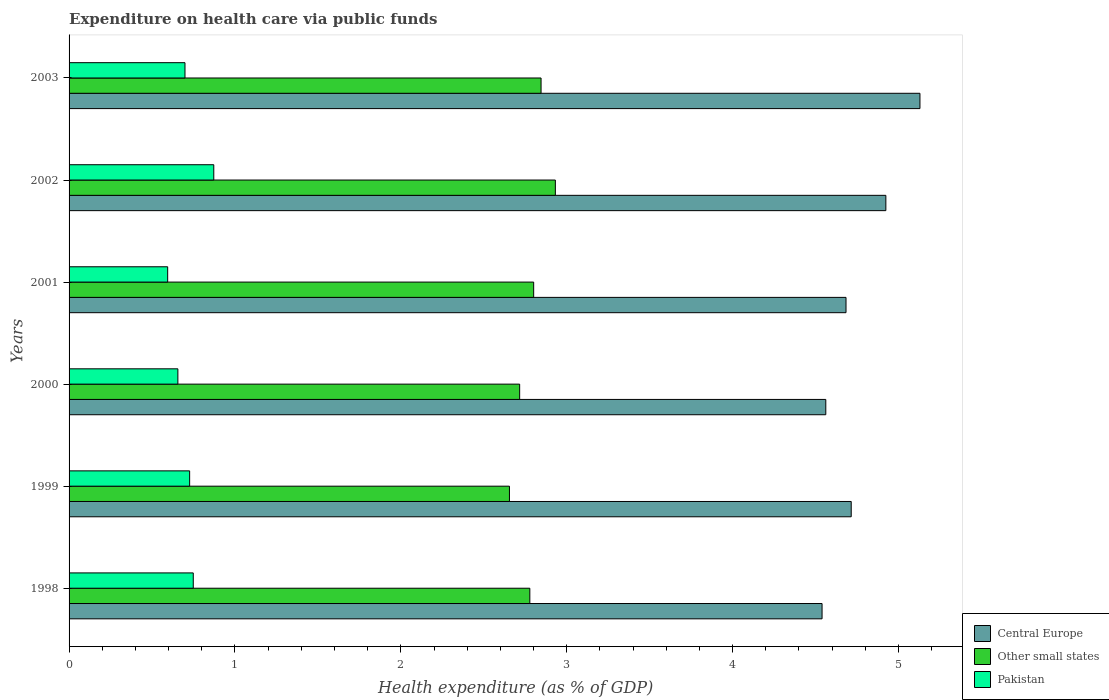How many groups of bars are there?
Ensure brevity in your answer.  6. How many bars are there on the 4th tick from the bottom?
Your answer should be very brief. 3. In how many cases, is the number of bars for a given year not equal to the number of legend labels?
Give a very brief answer. 0. What is the expenditure made on health care in Other small states in 2003?
Ensure brevity in your answer.  2.85. Across all years, what is the maximum expenditure made on health care in Other small states?
Provide a succinct answer. 2.93. Across all years, what is the minimum expenditure made on health care in Central Europe?
Make the answer very short. 4.54. In which year was the expenditure made on health care in Pakistan maximum?
Give a very brief answer. 2002. In which year was the expenditure made on health care in Other small states minimum?
Your response must be concise. 1999. What is the total expenditure made on health care in Pakistan in the graph?
Your answer should be compact. 4.3. What is the difference between the expenditure made on health care in Pakistan in 1998 and that in 2002?
Make the answer very short. -0.12. What is the difference between the expenditure made on health care in Other small states in 1998 and the expenditure made on health care in Pakistan in 2003?
Offer a very short reply. 2.08. What is the average expenditure made on health care in Other small states per year?
Give a very brief answer. 2.79. In the year 1999, what is the difference between the expenditure made on health care in Central Europe and expenditure made on health care in Pakistan?
Your response must be concise. 3.99. In how many years, is the expenditure made on health care in Pakistan greater than 4 %?
Offer a very short reply. 0. What is the ratio of the expenditure made on health care in Other small states in 2001 to that in 2003?
Your answer should be very brief. 0.98. Is the expenditure made on health care in Other small states in 2000 less than that in 2003?
Provide a short and direct response. Yes. What is the difference between the highest and the second highest expenditure made on health care in Pakistan?
Your response must be concise. 0.12. What is the difference between the highest and the lowest expenditure made on health care in Central Europe?
Your response must be concise. 0.59. What does the 1st bar from the top in 2002 represents?
Your answer should be compact. Pakistan. What does the 3rd bar from the bottom in 2001 represents?
Make the answer very short. Pakistan. Is it the case that in every year, the sum of the expenditure made on health care in Pakistan and expenditure made on health care in Other small states is greater than the expenditure made on health care in Central Europe?
Provide a short and direct response. No. How many bars are there?
Offer a terse response. 18. Are all the bars in the graph horizontal?
Make the answer very short. Yes. How many years are there in the graph?
Ensure brevity in your answer.  6. Does the graph contain grids?
Provide a succinct answer. No. How many legend labels are there?
Make the answer very short. 3. What is the title of the graph?
Provide a succinct answer. Expenditure on health care via public funds. What is the label or title of the X-axis?
Ensure brevity in your answer.  Health expenditure (as % of GDP). What is the Health expenditure (as % of GDP) in Central Europe in 1998?
Give a very brief answer. 4.54. What is the Health expenditure (as % of GDP) of Other small states in 1998?
Keep it short and to the point. 2.78. What is the Health expenditure (as % of GDP) in Pakistan in 1998?
Your answer should be compact. 0.75. What is the Health expenditure (as % of GDP) in Central Europe in 1999?
Give a very brief answer. 4.72. What is the Health expenditure (as % of GDP) in Other small states in 1999?
Your answer should be compact. 2.65. What is the Health expenditure (as % of GDP) in Pakistan in 1999?
Give a very brief answer. 0.73. What is the Health expenditure (as % of GDP) of Central Europe in 2000?
Your response must be concise. 4.56. What is the Health expenditure (as % of GDP) in Other small states in 2000?
Your response must be concise. 2.72. What is the Health expenditure (as % of GDP) in Pakistan in 2000?
Your response must be concise. 0.66. What is the Health expenditure (as % of GDP) in Central Europe in 2001?
Your answer should be compact. 4.68. What is the Health expenditure (as % of GDP) of Other small states in 2001?
Your response must be concise. 2.8. What is the Health expenditure (as % of GDP) of Pakistan in 2001?
Offer a very short reply. 0.59. What is the Health expenditure (as % of GDP) in Central Europe in 2002?
Your response must be concise. 4.92. What is the Health expenditure (as % of GDP) in Other small states in 2002?
Make the answer very short. 2.93. What is the Health expenditure (as % of GDP) of Pakistan in 2002?
Provide a succinct answer. 0.87. What is the Health expenditure (as % of GDP) in Central Europe in 2003?
Make the answer very short. 5.13. What is the Health expenditure (as % of GDP) in Other small states in 2003?
Offer a terse response. 2.85. What is the Health expenditure (as % of GDP) of Pakistan in 2003?
Give a very brief answer. 0.7. Across all years, what is the maximum Health expenditure (as % of GDP) of Central Europe?
Offer a very short reply. 5.13. Across all years, what is the maximum Health expenditure (as % of GDP) in Other small states?
Offer a terse response. 2.93. Across all years, what is the maximum Health expenditure (as % of GDP) of Pakistan?
Ensure brevity in your answer.  0.87. Across all years, what is the minimum Health expenditure (as % of GDP) of Central Europe?
Make the answer very short. 4.54. Across all years, what is the minimum Health expenditure (as % of GDP) in Other small states?
Keep it short and to the point. 2.65. Across all years, what is the minimum Health expenditure (as % of GDP) of Pakistan?
Make the answer very short. 0.59. What is the total Health expenditure (as % of GDP) of Central Europe in the graph?
Your answer should be compact. 28.55. What is the total Health expenditure (as % of GDP) in Other small states in the graph?
Your answer should be compact. 16.73. What is the total Health expenditure (as % of GDP) of Pakistan in the graph?
Your answer should be very brief. 4.3. What is the difference between the Health expenditure (as % of GDP) in Central Europe in 1998 and that in 1999?
Offer a terse response. -0.18. What is the difference between the Health expenditure (as % of GDP) of Other small states in 1998 and that in 1999?
Provide a short and direct response. 0.12. What is the difference between the Health expenditure (as % of GDP) in Pakistan in 1998 and that in 1999?
Your answer should be very brief. 0.02. What is the difference between the Health expenditure (as % of GDP) in Central Europe in 1998 and that in 2000?
Your answer should be compact. -0.02. What is the difference between the Health expenditure (as % of GDP) of Other small states in 1998 and that in 2000?
Make the answer very short. 0.06. What is the difference between the Health expenditure (as % of GDP) in Pakistan in 1998 and that in 2000?
Offer a terse response. 0.09. What is the difference between the Health expenditure (as % of GDP) of Central Europe in 1998 and that in 2001?
Provide a short and direct response. -0.14. What is the difference between the Health expenditure (as % of GDP) in Other small states in 1998 and that in 2001?
Provide a short and direct response. -0.02. What is the difference between the Health expenditure (as % of GDP) in Pakistan in 1998 and that in 2001?
Ensure brevity in your answer.  0.15. What is the difference between the Health expenditure (as % of GDP) of Central Europe in 1998 and that in 2002?
Provide a short and direct response. -0.38. What is the difference between the Health expenditure (as % of GDP) of Other small states in 1998 and that in 2002?
Your answer should be very brief. -0.15. What is the difference between the Health expenditure (as % of GDP) in Pakistan in 1998 and that in 2002?
Keep it short and to the point. -0.12. What is the difference between the Health expenditure (as % of GDP) in Central Europe in 1998 and that in 2003?
Offer a very short reply. -0.59. What is the difference between the Health expenditure (as % of GDP) of Other small states in 1998 and that in 2003?
Offer a terse response. -0.07. What is the difference between the Health expenditure (as % of GDP) of Pakistan in 1998 and that in 2003?
Provide a succinct answer. 0.05. What is the difference between the Health expenditure (as % of GDP) of Central Europe in 1999 and that in 2000?
Keep it short and to the point. 0.15. What is the difference between the Health expenditure (as % of GDP) of Other small states in 1999 and that in 2000?
Offer a terse response. -0.06. What is the difference between the Health expenditure (as % of GDP) in Pakistan in 1999 and that in 2000?
Your answer should be compact. 0.07. What is the difference between the Health expenditure (as % of GDP) of Central Europe in 1999 and that in 2001?
Your answer should be compact. 0.03. What is the difference between the Health expenditure (as % of GDP) in Other small states in 1999 and that in 2001?
Make the answer very short. -0.15. What is the difference between the Health expenditure (as % of GDP) of Pakistan in 1999 and that in 2001?
Make the answer very short. 0.13. What is the difference between the Health expenditure (as % of GDP) of Central Europe in 1999 and that in 2002?
Your response must be concise. -0.21. What is the difference between the Health expenditure (as % of GDP) in Other small states in 1999 and that in 2002?
Keep it short and to the point. -0.28. What is the difference between the Health expenditure (as % of GDP) in Pakistan in 1999 and that in 2002?
Provide a succinct answer. -0.15. What is the difference between the Health expenditure (as % of GDP) in Central Europe in 1999 and that in 2003?
Offer a very short reply. -0.41. What is the difference between the Health expenditure (as % of GDP) in Other small states in 1999 and that in 2003?
Ensure brevity in your answer.  -0.19. What is the difference between the Health expenditure (as % of GDP) of Pakistan in 1999 and that in 2003?
Provide a short and direct response. 0.03. What is the difference between the Health expenditure (as % of GDP) in Central Europe in 2000 and that in 2001?
Give a very brief answer. -0.12. What is the difference between the Health expenditure (as % of GDP) in Other small states in 2000 and that in 2001?
Keep it short and to the point. -0.08. What is the difference between the Health expenditure (as % of GDP) in Pakistan in 2000 and that in 2001?
Ensure brevity in your answer.  0.06. What is the difference between the Health expenditure (as % of GDP) of Central Europe in 2000 and that in 2002?
Provide a succinct answer. -0.36. What is the difference between the Health expenditure (as % of GDP) in Other small states in 2000 and that in 2002?
Ensure brevity in your answer.  -0.22. What is the difference between the Health expenditure (as % of GDP) of Pakistan in 2000 and that in 2002?
Offer a terse response. -0.22. What is the difference between the Health expenditure (as % of GDP) in Central Europe in 2000 and that in 2003?
Your answer should be compact. -0.57. What is the difference between the Health expenditure (as % of GDP) in Other small states in 2000 and that in 2003?
Offer a terse response. -0.13. What is the difference between the Health expenditure (as % of GDP) of Pakistan in 2000 and that in 2003?
Ensure brevity in your answer.  -0.04. What is the difference between the Health expenditure (as % of GDP) of Central Europe in 2001 and that in 2002?
Your answer should be compact. -0.24. What is the difference between the Health expenditure (as % of GDP) in Other small states in 2001 and that in 2002?
Keep it short and to the point. -0.13. What is the difference between the Health expenditure (as % of GDP) of Pakistan in 2001 and that in 2002?
Offer a terse response. -0.28. What is the difference between the Health expenditure (as % of GDP) of Central Europe in 2001 and that in 2003?
Ensure brevity in your answer.  -0.45. What is the difference between the Health expenditure (as % of GDP) of Other small states in 2001 and that in 2003?
Give a very brief answer. -0.04. What is the difference between the Health expenditure (as % of GDP) in Pakistan in 2001 and that in 2003?
Make the answer very short. -0.1. What is the difference between the Health expenditure (as % of GDP) in Central Europe in 2002 and that in 2003?
Provide a short and direct response. -0.21. What is the difference between the Health expenditure (as % of GDP) in Other small states in 2002 and that in 2003?
Give a very brief answer. 0.09. What is the difference between the Health expenditure (as % of GDP) in Pakistan in 2002 and that in 2003?
Give a very brief answer. 0.17. What is the difference between the Health expenditure (as % of GDP) in Central Europe in 1998 and the Health expenditure (as % of GDP) in Other small states in 1999?
Offer a terse response. 1.88. What is the difference between the Health expenditure (as % of GDP) in Central Europe in 1998 and the Health expenditure (as % of GDP) in Pakistan in 1999?
Ensure brevity in your answer.  3.81. What is the difference between the Health expenditure (as % of GDP) of Other small states in 1998 and the Health expenditure (as % of GDP) of Pakistan in 1999?
Make the answer very short. 2.05. What is the difference between the Health expenditure (as % of GDP) of Central Europe in 1998 and the Health expenditure (as % of GDP) of Other small states in 2000?
Ensure brevity in your answer.  1.82. What is the difference between the Health expenditure (as % of GDP) of Central Europe in 1998 and the Health expenditure (as % of GDP) of Pakistan in 2000?
Your answer should be compact. 3.88. What is the difference between the Health expenditure (as % of GDP) in Other small states in 1998 and the Health expenditure (as % of GDP) in Pakistan in 2000?
Offer a terse response. 2.12. What is the difference between the Health expenditure (as % of GDP) in Central Europe in 1998 and the Health expenditure (as % of GDP) in Other small states in 2001?
Make the answer very short. 1.74. What is the difference between the Health expenditure (as % of GDP) in Central Europe in 1998 and the Health expenditure (as % of GDP) in Pakistan in 2001?
Your response must be concise. 3.94. What is the difference between the Health expenditure (as % of GDP) in Other small states in 1998 and the Health expenditure (as % of GDP) in Pakistan in 2001?
Make the answer very short. 2.18. What is the difference between the Health expenditure (as % of GDP) in Central Europe in 1998 and the Health expenditure (as % of GDP) in Other small states in 2002?
Offer a terse response. 1.61. What is the difference between the Health expenditure (as % of GDP) of Central Europe in 1998 and the Health expenditure (as % of GDP) of Pakistan in 2002?
Give a very brief answer. 3.67. What is the difference between the Health expenditure (as % of GDP) in Other small states in 1998 and the Health expenditure (as % of GDP) in Pakistan in 2002?
Your answer should be compact. 1.91. What is the difference between the Health expenditure (as % of GDP) of Central Europe in 1998 and the Health expenditure (as % of GDP) of Other small states in 2003?
Your response must be concise. 1.69. What is the difference between the Health expenditure (as % of GDP) in Central Europe in 1998 and the Health expenditure (as % of GDP) in Pakistan in 2003?
Offer a terse response. 3.84. What is the difference between the Health expenditure (as % of GDP) in Other small states in 1998 and the Health expenditure (as % of GDP) in Pakistan in 2003?
Offer a terse response. 2.08. What is the difference between the Health expenditure (as % of GDP) of Central Europe in 1999 and the Health expenditure (as % of GDP) of Other small states in 2000?
Offer a very short reply. 2. What is the difference between the Health expenditure (as % of GDP) in Central Europe in 1999 and the Health expenditure (as % of GDP) in Pakistan in 2000?
Provide a short and direct response. 4.06. What is the difference between the Health expenditure (as % of GDP) in Other small states in 1999 and the Health expenditure (as % of GDP) in Pakistan in 2000?
Your answer should be compact. 2. What is the difference between the Health expenditure (as % of GDP) of Central Europe in 1999 and the Health expenditure (as % of GDP) of Other small states in 2001?
Your answer should be compact. 1.91. What is the difference between the Health expenditure (as % of GDP) in Central Europe in 1999 and the Health expenditure (as % of GDP) in Pakistan in 2001?
Ensure brevity in your answer.  4.12. What is the difference between the Health expenditure (as % of GDP) of Other small states in 1999 and the Health expenditure (as % of GDP) of Pakistan in 2001?
Make the answer very short. 2.06. What is the difference between the Health expenditure (as % of GDP) in Central Europe in 1999 and the Health expenditure (as % of GDP) in Other small states in 2002?
Make the answer very short. 1.78. What is the difference between the Health expenditure (as % of GDP) in Central Europe in 1999 and the Health expenditure (as % of GDP) in Pakistan in 2002?
Provide a short and direct response. 3.84. What is the difference between the Health expenditure (as % of GDP) in Other small states in 1999 and the Health expenditure (as % of GDP) in Pakistan in 2002?
Make the answer very short. 1.78. What is the difference between the Health expenditure (as % of GDP) of Central Europe in 1999 and the Health expenditure (as % of GDP) of Other small states in 2003?
Make the answer very short. 1.87. What is the difference between the Health expenditure (as % of GDP) in Central Europe in 1999 and the Health expenditure (as % of GDP) in Pakistan in 2003?
Offer a terse response. 4.02. What is the difference between the Health expenditure (as % of GDP) of Other small states in 1999 and the Health expenditure (as % of GDP) of Pakistan in 2003?
Ensure brevity in your answer.  1.96. What is the difference between the Health expenditure (as % of GDP) in Central Europe in 2000 and the Health expenditure (as % of GDP) in Other small states in 2001?
Your answer should be very brief. 1.76. What is the difference between the Health expenditure (as % of GDP) of Central Europe in 2000 and the Health expenditure (as % of GDP) of Pakistan in 2001?
Your answer should be very brief. 3.97. What is the difference between the Health expenditure (as % of GDP) of Other small states in 2000 and the Health expenditure (as % of GDP) of Pakistan in 2001?
Keep it short and to the point. 2.12. What is the difference between the Health expenditure (as % of GDP) of Central Europe in 2000 and the Health expenditure (as % of GDP) of Other small states in 2002?
Your answer should be compact. 1.63. What is the difference between the Health expenditure (as % of GDP) of Central Europe in 2000 and the Health expenditure (as % of GDP) of Pakistan in 2002?
Offer a very short reply. 3.69. What is the difference between the Health expenditure (as % of GDP) of Other small states in 2000 and the Health expenditure (as % of GDP) of Pakistan in 2002?
Offer a very short reply. 1.84. What is the difference between the Health expenditure (as % of GDP) of Central Europe in 2000 and the Health expenditure (as % of GDP) of Other small states in 2003?
Your answer should be compact. 1.72. What is the difference between the Health expenditure (as % of GDP) of Central Europe in 2000 and the Health expenditure (as % of GDP) of Pakistan in 2003?
Offer a terse response. 3.86. What is the difference between the Health expenditure (as % of GDP) in Other small states in 2000 and the Health expenditure (as % of GDP) in Pakistan in 2003?
Provide a succinct answer. 2.02. What is the difference between the Health expenditure (as % of GDP) in Central Europe in 2001 and the Health expenditure (as % of GDP) in Other small states in 2002?
Offer a very short reply. 1.75. What is the difference between the Health expenditure (as % of GDP) in Central Europe in 2001 and the Health expenditure (as % of GDP) in Pakistan in 2002?
Ensure brevity in your answer.  3.81. What is the difference between the Health expenditure (as % of GDP) of Other small states in 2001 and the Health expenditure (as % of GDP) of Pakistan in 2002?
Provide a short and direct response. 1.93. What is the difference between the Health expenditure (as % of GDP) in Central Europe in 2001 and the Health expenditure (as % of GDP) in Other small states in 2003?
Provide a succinct answer. 1.84. What is the difference between the Health expenditure (as % of GDP) in Central Europe in 2001 and the Health expenditure (as % of GDP) in Pakistan in 2003?
Your answer should be very brief. 3.98. What is the difference between the Health expenditure (as % of GDP) of Other small states in 2001 and the Health expenditure (as % of GDP) of Pakistan in 2003?
Your answer should be very brief. 2.1. What is the difference between the Health expenditure (as % of GDP) of Central Europe in 2002 and the Health expenditure (as % of GDP) of Other small states in 2003?
Your answer should be very brief. 2.08. What is the difference between the Health expenditure (as % of GDP) of Central Europe in 2002 and the Health expenditure (as % of GDP) of Pakistan in 2003?
Your response must be concise. 4.23. What is the difference between the Health expenditure (as % of GDP) in Other small states in 2002 and the Health expenditure (as % of GDP) in Pakistan in 2003?
Offer a terse response. 2.23. What is the average Health expenditure (as % of GDP) in Central Europe per year?
Make the answer very short. 4.76. What is the average Health expenditure (as % of GDP) of Other small states per year?
Offer a very short reply. 2.79. What is the average Health expenditure (as % of GDP) in Pakistan per year?
Provide a short and direct response. 0.72. In the year 1998, what is the difference between the Health expenditure (as % of GDP) in Central Europe and Health expenditure (as % of GDP) in Other small states?
Provide a succinct answer. 1.76. In the year 1998, what is the difference between the Health expenditure (as % of GDP) in Central Europe and Health expenditure (as % of GDP) in Pakistan?
Your answer should be compact. 3.79. In the year 1998, what is the difference between the Health expenditure (as % of GDP) of Other small states and Health expenditure (as % of GDP) of Pakistan?
Your answer should be very brief. 2.03. In the year 1999, what is the difference between the Health expenditure (as % of GDP) in Central Europe and Health expenditure (as % of GDP) in Other small states?
Ensure brevity in your answer.  2.06. In the year 1999, what is the difference between the Health expenditure (as % of GDP) in Central Europe and Health expenditure (as % of GDP) in Pakistan?
Keep it short and to the point. 3.99. In the year 1999, what is the difference between the Health expenditure (as % of GDP) in Other small states and Health expenditure (as % of GDP) in Pakistan?
Your response must be concise. 1.93. In the year 2000, what is the difference between the Health expenditure (as % of GDP) in Central Europe and Health expenditure (as % of GDP) in Other small states?
Ensure brevity in your answer.  1.85. In the year 2000, what is the difference between the Health expenditure (as % of GDP) in Central Europe and Health expenditure (as % of GDP) in Pakistan?
Provide a succinct answer. 3.91. In the year 2000, what is the difference between the Health expenditure (as % of GDP) of Other small states and Health expenditure (as % of GDP) of Pakistan?
Offer a very short reply. 2.06. In the year 2001, what is the difference between the Health expenditure (as % of GDP) of Central Europe and Health expenditure (as % of GDP) of Other small states?
Ensure brevity in your answer.  1.88. In the year 2001, what is the difference between the Health expenditure (as % of GDP) in Central Europe and Health expenditure (as % of GDP) in Pakistan?
Ensure brevity in your answer.  4.09. In the year 2001, what is the difference between the Health expenditure (as % of GDP) in Other small states and Health expenditure (as % of GDP) in Pakistan?
Offer a terse response. 2.21. In the year 2002, what is the difference between the Health expenditure (as % of GDP) in Central Europe and Health expenditure (as % of GDP) in Other small states?
Provide a succinct answer. 1.99. In the year 2002, what is the difference between the Health expenditure (as % of GDP) of Central Europe and Health expenditure (as % of GDP) of Pakistan?
Keep it short and to the point. 4.05. In the year 2002, what is the difference between the Health expenditure (as % of GDP) of Other small states and Health expenditure (as % of GDP) of Pakistan?
Your answer should be compact. 2.06. In the year 2003, what is the difference between the Health expenditure (as % of GDP) of Central Europe and Health expenditure (as % of GDP) of Other small states?
Your answer should be compact. 2.28. In the year 2003, what is the difference between the Health expenditure (as % of GDP) of Central Europe and Health expenditure (as % of GDP) of Pakistan?
Ensure brevity in your answer.  4.43. In the year 2003, what is the difference between the Health expenditure (as % of GDP) in Other small states and Health expenditure (as % of GDP) in Pakistan?
Your answer should be very brief. 2.15. What is the ratio of the Health expenditure (as % of GDP) of Central Europe in 1998 to that in 1999?
Offer a very short reply. 0.96. What is the ratio of the Health expenditure (as % of GDP) in Other small states in 1998 to that in 1999?
Make the answer very short. 1.05. What is the ratio of the Health expenditure (as % of GDP) in Pakistan in 1998 to that in 1999?
Provide a succinct answer. 1.03. What is the ratio of the Health expenditure (as % of GDP) in Other small states in 1998 to that in 2000?
Make the answer very short. 1.02. What is the ratio of the Health expenditure (as % of GDP) of Pakistan in 1998 to that in 2000?
Offer a very short reply. 1.14. What is the ratio of the Health expenditure (as % of GDP) of Central Europe in 1998 to that in 2001?
Ensure brevity in your answer.  0.97. What is the ratio of the Health expenditure (as % of GDP) of Other small states in 1998 to that in 2001?
Provide a short and direct response. 0.99. What is the ratio of the Health expenditure (as % of GDP) in Pakistan in 1998 to that in 2001?
Provide a short and direct response. 1.26. What is the ratio of the Health expenditure (as % of GDP) in Central Europe in 1998 to that in 2002?
Offer a very short reply. 0.92. What is the ratio of the Health expenditure (as % of GDP) of Other small states in 1998 to that in 2002?
Your response must be concise. 0.95. What is the ratio of the Health expenditure (as % of GDP) in Pakistan in 1998 to that in 2002?
Offer a terse response. 0.86. What is the ratio of the Health expenditure (as % of GDP) of Central Europe in 1998 to that in 2003?
Provide a short and direct response. 0.89. What is the ratio of the Health expenditure (as % of GDP) of Other small states in 1998 to that in 2003?
Give a very brief answer. 0.98. What is the ratio of the Health expenditure (as % of GDP) in Pakistan in 1998 to that in 2003?
Provide a succinct answer. 1.07. What is the ratio of the Health expenditure (as % of GDP) in Central Europe in 1999 to that in 2000?
Provide a succinct answer. 1.03. What is the ratio of the Health expenditure (as % of GDP) of Other small states in 1999 to that in 2000?
Your answer should be compact. 0.98. What is the ratio of the Health expenditure (as % of GDP) in Pakistan in 1999 to that in 2000?
Offer a very short reply. 1.11. What is the ratio of the Health expenditure (as % of GDP) of Central Europe in 1999 to that in 2001?
Your answer should be very brief. 1.01. What is the ratio of the Health expenditure (as % of GDP) in Other small states in 1999 to that in 2001?
Offer a very short reply. 0.95. What is the ratio of the Health expenditure (as % of GDP) of Pakistan in 1999 to that in 2001?
Your answer should be very brief. 1.22. What is the ratio of the Health expenditure (as % of GDP) in Central Europe in 1999 to that in 2002?
Provide a short and direct response. 0.96. What is the ratio of the Health expenditure (as % of GDP) in Other small states in 1999 to that in 2002?
Provide a short and direct response. 0.91. What is the ratio of the Health expenditure (as % of GDP) of Pakistan in 1999 to that in 2002?
Offer a terse response. 0.83. What is the ratio of the Health expenditure (as % of GDP) of Central Europe in 1999 to that in 2003?
Offer a terse response. 0.92. What is the ratio of the Health expenditure (as % of GDP) of Other small states in 1999 to that in 2003?
Your answer should be compact. 0.93. What is the ratio of the Health expenditure (as % of GDP) of Pakistan in 1999 to that in 2003?
Offer a terse response. 1.04. What is the ratio of the Health expenditure (as % of GDP) in Other small states in 2000 to that in 2001?
Ensure brevity in your answer.  0.97. What is the ratio of the Health expenditure (as % of GDP) in Pakistan in 2000 to that in 2001?
Your answer should be very brief. 1.1. What is the ratio of the Health expenditure (as % of GDP) in Central Europe in 2000 to that in 2002?
Provide a short and direct response. 0.93. What is the ratio of the Health expenditure (as % of GDP) in Other small states in 2000 to that in 2002?
Keep it short and to the point. 0.93. What is the ratio of the Health expenditure (as % of GDP) in Pakistan in 2000 to that in 2002?
Provide a short and direct response. 0.75. What is the ratio of the Health expenditure (as % of GDP) in Central Europe in 2000 to that in 2003?
Provide a short and direct response. 0.89. What is the ratio of the Health expenditure (as % of GDP) in Other small states in 2000 to that in 2003?
Offer a very short reply. 0.95. What is the ratio of the Health expenditure (as % of GDP) of Pakistan in 2000 to that in 2003?
Give a very brief answer. 0.94. What is the ratio of the Health expenditure (as % of GDP) in Central Europe in 2001 to that in 2002?
Provide a succinct answer. 0.95. What is the ratio of the Health expenditure (as % of GDP) in Other small states in 2001 to that in 2002?
Your answer should be compact. 0.96. What is the ratio of the Health expenditure (as % of GDP) of Pakistan in 2001 to that in 2002?
Your answer should be very brief. 0.68. What is the ratio of the Health expenditure (as % of GDP) of Central Europe in 2001 to that in 2003?
Make the answer very short. 0.91. What is the ratio of the Health expenditure (as % of GDP) of Other small states in 2001 to that in 2003?
Give a very brief answer. 0.98. What is the ratio of the Health expenditure (as % of GDP) of Pakistan in 2001 to that in 2003?
Provide a short and direct response. 0.85. What is the ratio of the Health expenditure (as % of GDP) of Central Europe in 2002 to that in 2003?
Keep it short and to the point. 0.96. What is the ratio of the Health expenditure (as % of GDP) of Other small states in 2002 to that in 2003?
Provide a short and direct response. 1.03. What is the ratio of the Health expenditure (as % of GDP) of Pakistan in 2002 to that in 2003?
Ensure brevity in your answer.  1.25. What is the difference between the highest and the second highest Health expenditure (as % of GDP) of Central Europe?
Keep it short and to the point. 0.21. What is the difference between the highest and the second highest Health expenditure (as % of GDP) in Other small states?
Offer a very short reply. 0.09. What is the difference between the highest and the second highest Health expenditure (as % of GDP) in Pakistan?
Give a very brief answer. 0.12. What is the difference between the highest and the lowest Health expenditure (as % of GDP) in Central Europe?
Your response must be concise. 0.59. What is the difference between the highest and the lowest Health expenditure (as % of GDP) of Other small states?
Your response must be concise. 0.28. What is the difference between the highest and the lowest Health expenditure (as % of GDP) of Pakistan?
Offer a terse response. 0.28. 